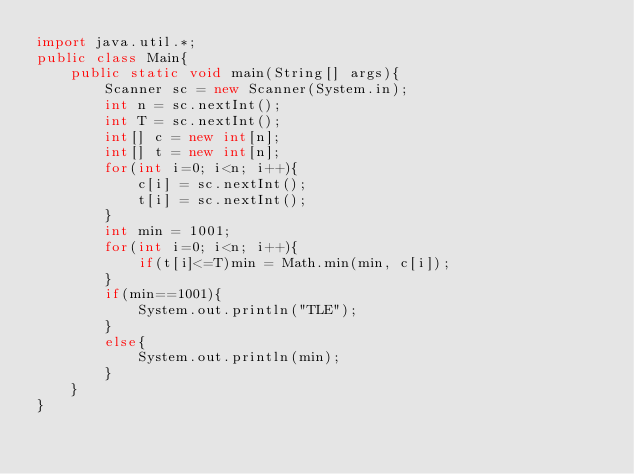Convert code to text. <code><loc_0><loc_0><loc_500><loc_500><_Java_>import java.util.*;
public class Main{
	public static void main(String[] args){
		Scanner sc = new Scanner(System.in);
		int n = sc.nextInt();
		int T = sc.nextInt();
		int[] c = new int[n];
		int[] t = new int[n];
		for(int i=0; i<n; i++){
			c[i] = sc.nextInt();
			t[i] = sc.nextInt();
		}
		int min = 1001;
		for(int i=0; i<n; i++){
			if(t[i]<=T)min = Math.min(min, c[i]);
		}
		if(min==1001){
			System.out.println("TLE");
		}
		else{
			System.out.println(min);
		}
	}
}</code> 